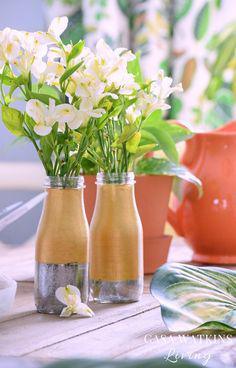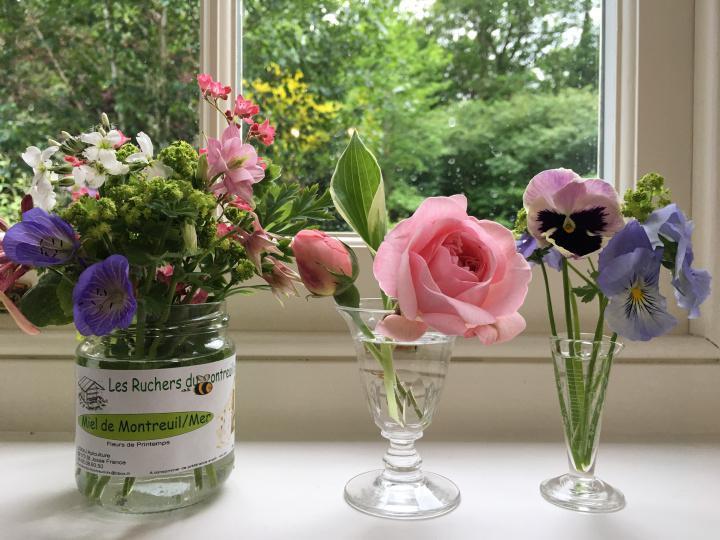The first image is the image on the left, the second image is the image on the right. For the images displayed, is the sentence "Right image features a variety of flowers, including roses." factually correct? Answer yes or no. Yes. The first image is the image on the left, the second image is the image on the right. For the images shown, is this caption "Purple hyacinth and moss are growing in at least one white planter in the image on the left." true? Answer yes or no. No. 